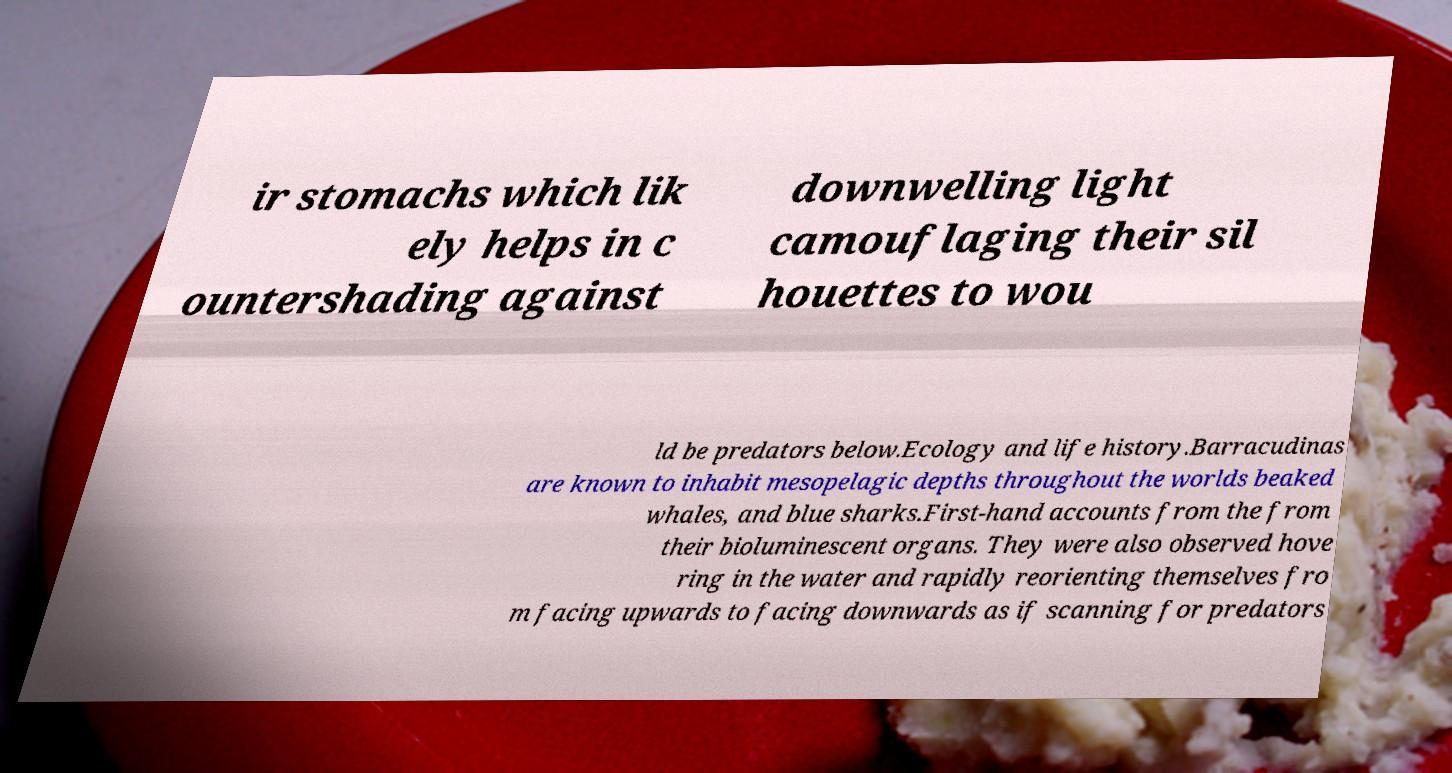Please identify and transcribe the text found in this image. ir stomachs which lik ely helps in c ountershading against downwelling light camouflaging their sil houettes to wou ld be predators below.Ecology and life history.Barracudinas are known to inhabit mesopelagic depths throughout the worlds beaked whales, and blue sharks.First-hand accounts from the from their bioluminescent organs. They were also observed hove ring in the water and rapidly reorienting themselves fro m facing upwards to facing downwards as if scanning for predators 